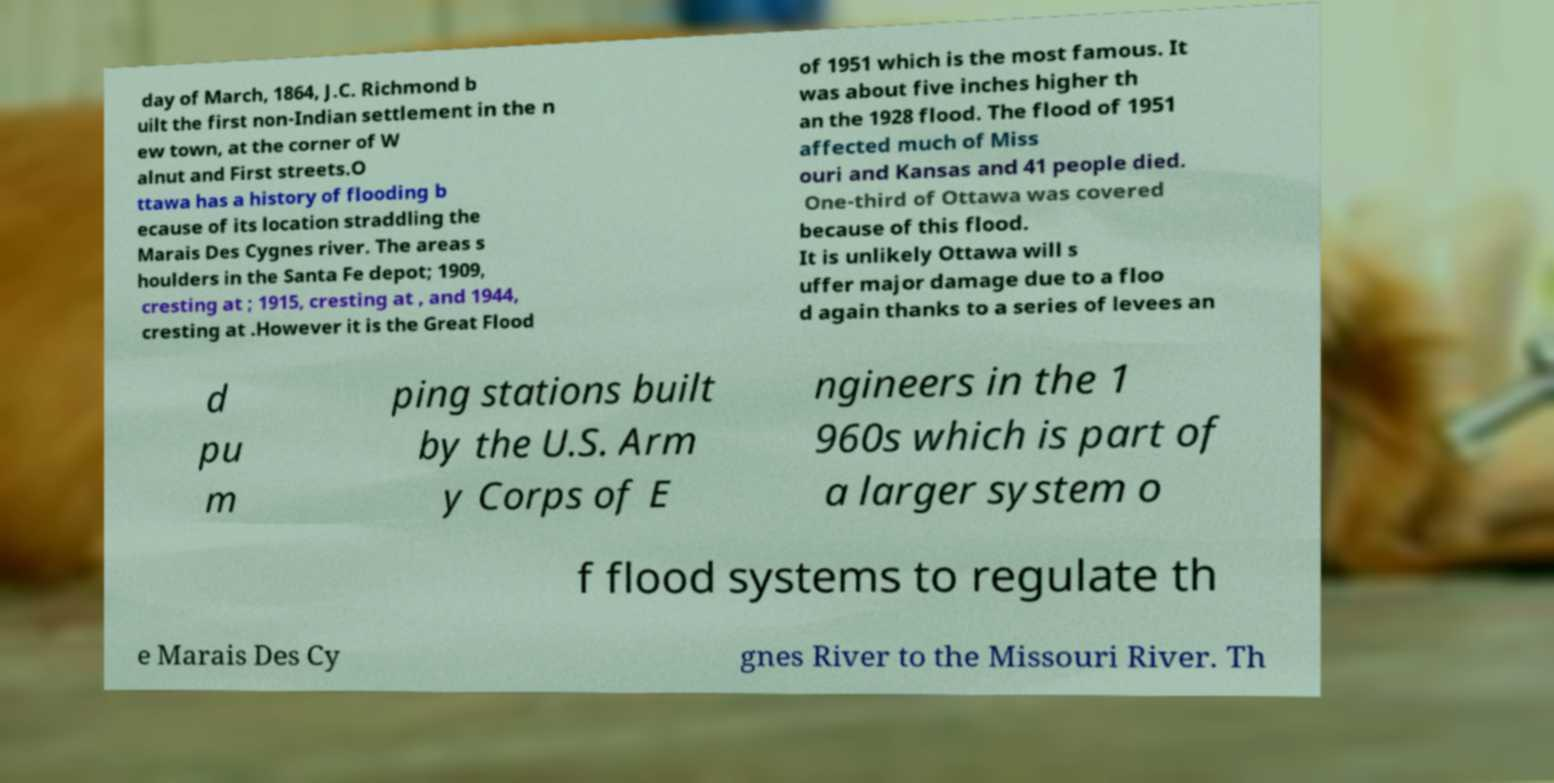What messages or text are displayed in this image? I need them in a readable, typed format. day of March, 1864, J.C. Richmond b uilt the first non-Indian settlement in the n ew town, at the corner of W alnut and First streets.O ttawa has a history of flooding b ecause of its location straddling the Marais Des Cygnes river. The areas s houlders in the Santa Fe depot; 1909, cresting at ; 1915, cresting at , and 1944, cresting at .However it is the Great Flood of 1951 which is the most famous. It was about five inches higher th an the 1928 flood. The flood of 1951 affected much of Miss ouri and Kansas and 41 people died. One-third of Ottawa was covered because of this flood. It is unlikely Ottawa will s uffer major damage due to a floo d again thanks to a series of levees an d pu m ping stations built by the U.S. Arm y Corps of E ngineers in the 1 960s which is part of a larger system o f flood systems to regulate th e Marais Des Cy gnes River to the Missouri River. Th 